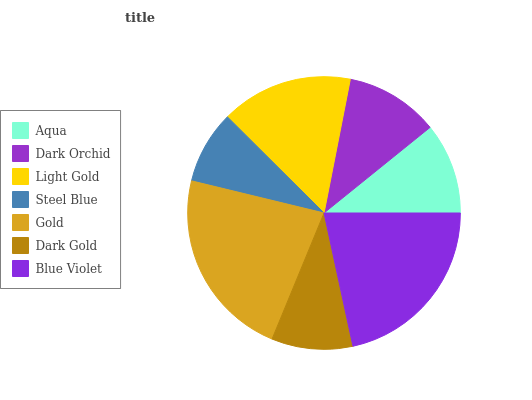Is Steel Blue the minimum?
Answer yes or no. Yes. Is Gold the maximum?
Answer yes or no. Yes. Is Dark Orchid the minimum?
Answer yes or no. No. Is Dark Orchid the maximum?
Answer yes or no. No. Is Dark Orchid greater than Aqua?
Answer yes or no. Yes. Is Aqua less than Dark Orchid?
Answer yes or no. Yes. Is Aqua greater than Dark Orchid?
Answer yes or no. No. Is Dark Orchid less than Aqua?
Answer yes or no. No. Is Dark Orchid the high median?
Answer yes or no. Yes. Is Dark Orchid the low median?
Answer yes or no. Yes. Is Dark Gold the high median?
Answer yes or no. No. Is Blue Violet the low median?
Answer yes or no. No. 